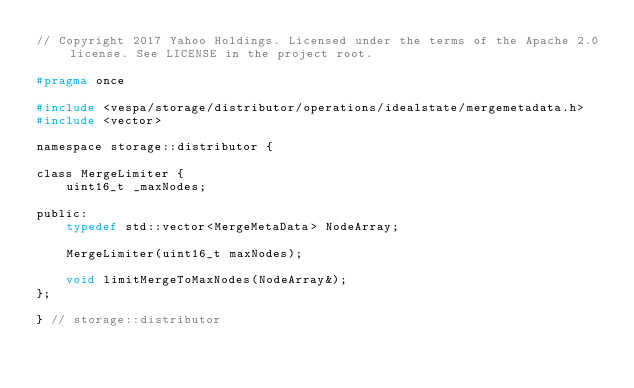<code> <loc_0><loc_0><loc_500><loc_500><_C_>// Copyright 2017 Yahoo Holdings. Licensed under the terms of the Apache 2.0 license. See LICENSE in the project root.

#pragma once

#include <vespa/storage/distributor/operations/idealstate/mergemetadata.h>
#include <vector>

namespace storage::distributor {

class MergeLimiter {
    uint16_t _maxNodes;

public:
    typedef std::vector<MergeMetaData> NodeArray;

    MergeLimiter(uint16_t maxNodes);

    void limitMergeToMaxNodes(NodeArray&);
};

} // storage::distributor
</code> 